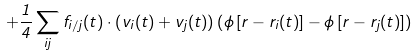<formula> <loc_0><loc_0><loc_500><loc_500>+ \frac { 1 } { 4 } \sum _ { i j } { f } _ { i / j } ( t ) \cdot \left ( { v } _ { i } ( t ) + { v } _ { j } ( t ) \right ) \left ( \phi \left [ { r } - { r } _ { i } ( t ) \right ] - \phi \left [ { r } - { r } _ { j } ( t ) \right ] \right )</formula> 